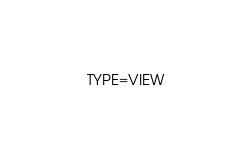Convert code to text. <code><loc_0><loc_0><loc_500><loc_500><_VisualBasic_>TYPE=VIEW</code> 